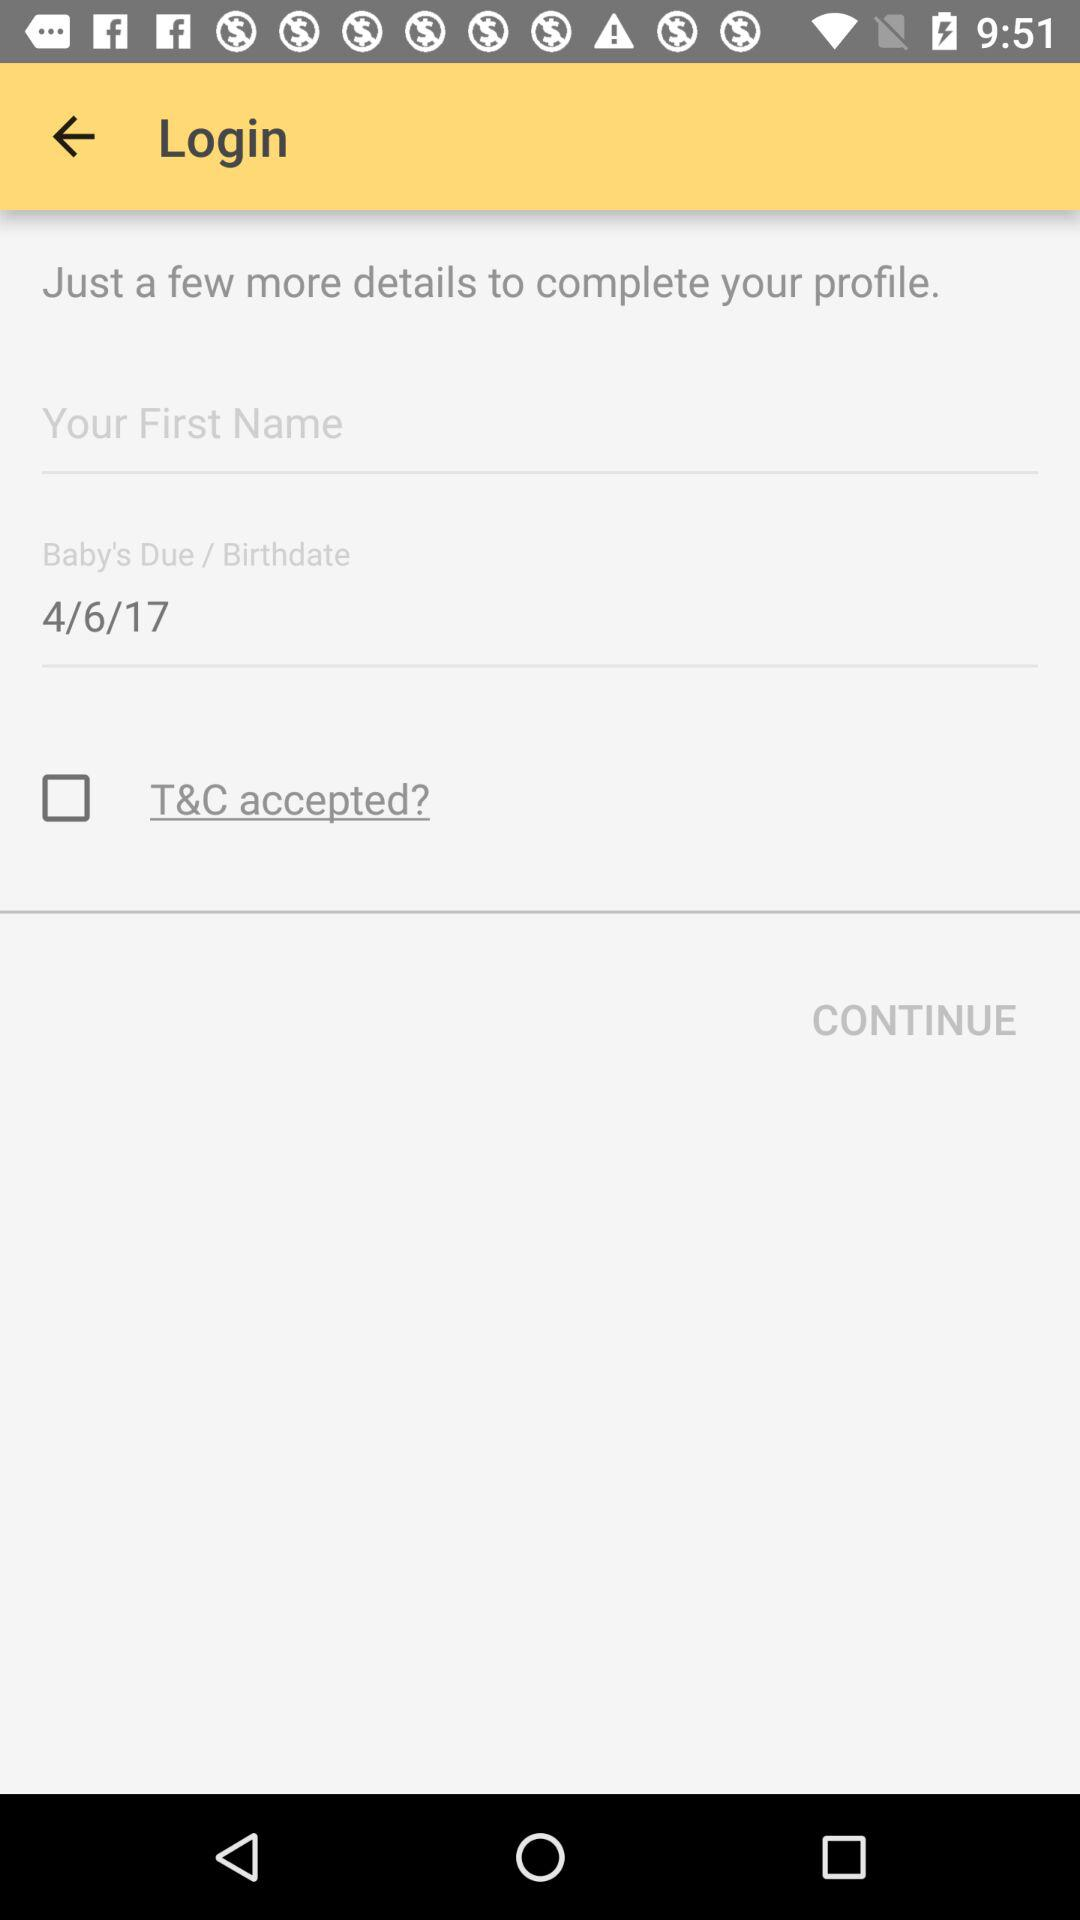What is the birthday date? The birthday date is April 6, 2017. 